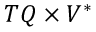Convert formula to latex. <formula><loc_0><loc_0><loc_500><loc_500>T Q \times V ^ { * }</formula> 